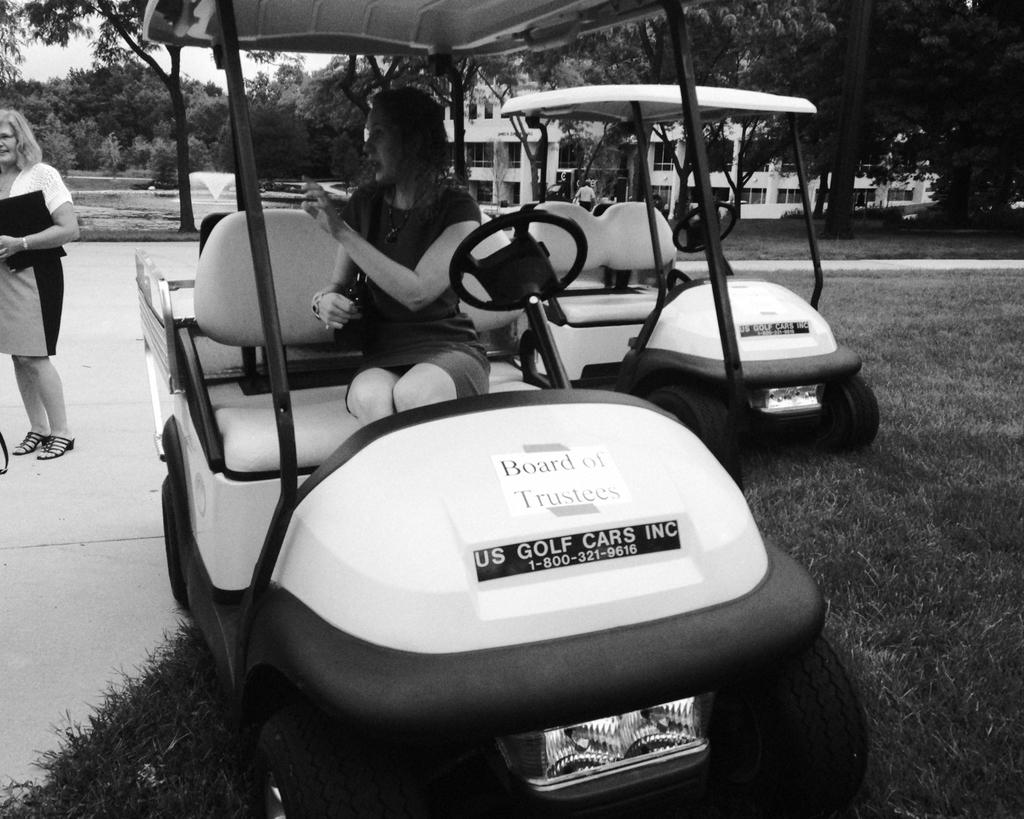What is the main subject of the image? There is a person sitting in a vehicle in the image. Can you describe the setting of the image? There is a person standing in the background of the image, along with other vehicles and trees. The sky is also visible in the background. What is the color scheme of the image? The image is in black and white. What type of organization is being discussed in the image? There is no organization mentioned or depicted in the image. Can you tell me how many copies of the vehicle are present in the image? There is only one vehicle visible in the image, so there is no need for copies. 